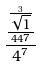Convert formula to latex. <formula><loc_0><loc_0><loc_500><loc_500>\frac { \frac { \frac { 3 } { \sqrt { 1 } } } { 4 4 7 } } { 4 ^ { 7 } }</formula> 